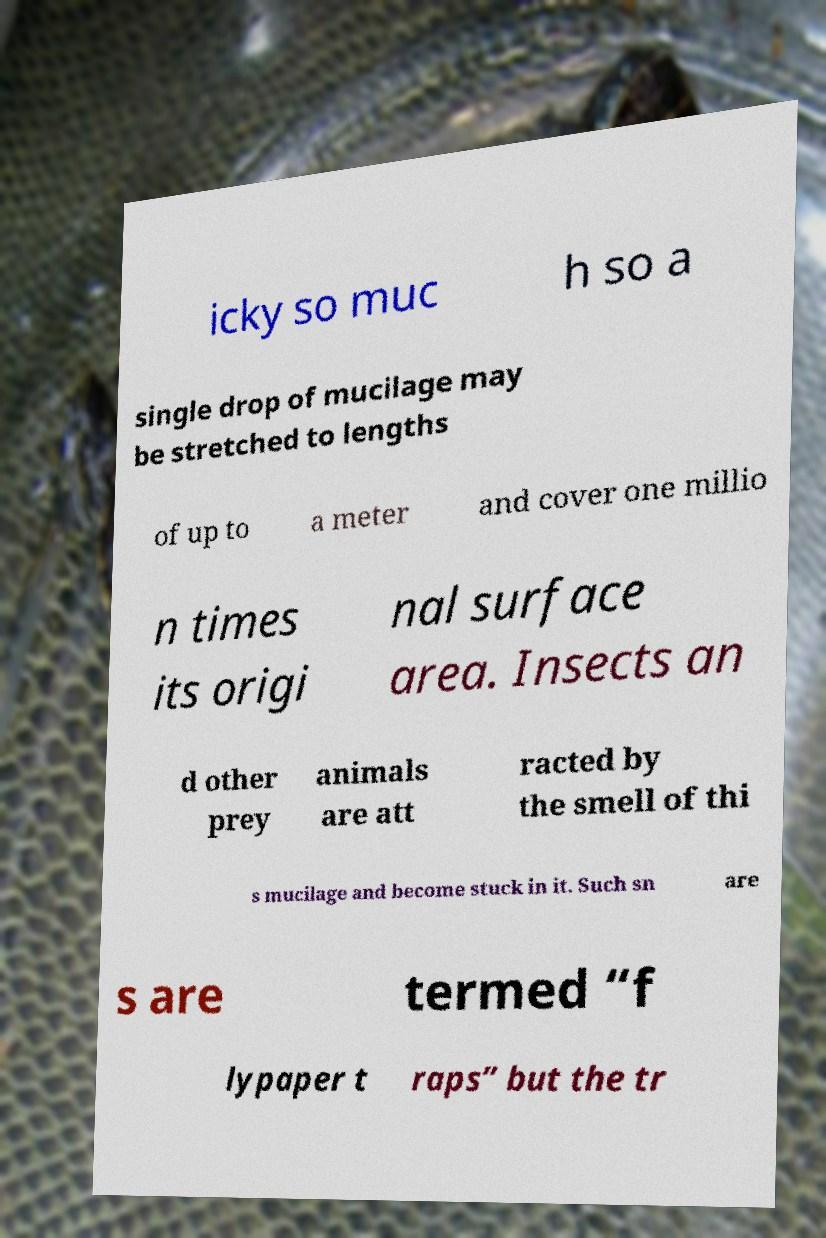What messages or text are displayed in this image? I need them in a readable, typed format. icky so muc h so a single drop of mucilage may be stretched to lengths of up to a meter and cover one millio n times its origi nal surface area. Insects an d other prey animals are att racted by the smell of thi s mucilage and become stuck in it. Such sn are s are termed “f lypaper t raps” but the tr 